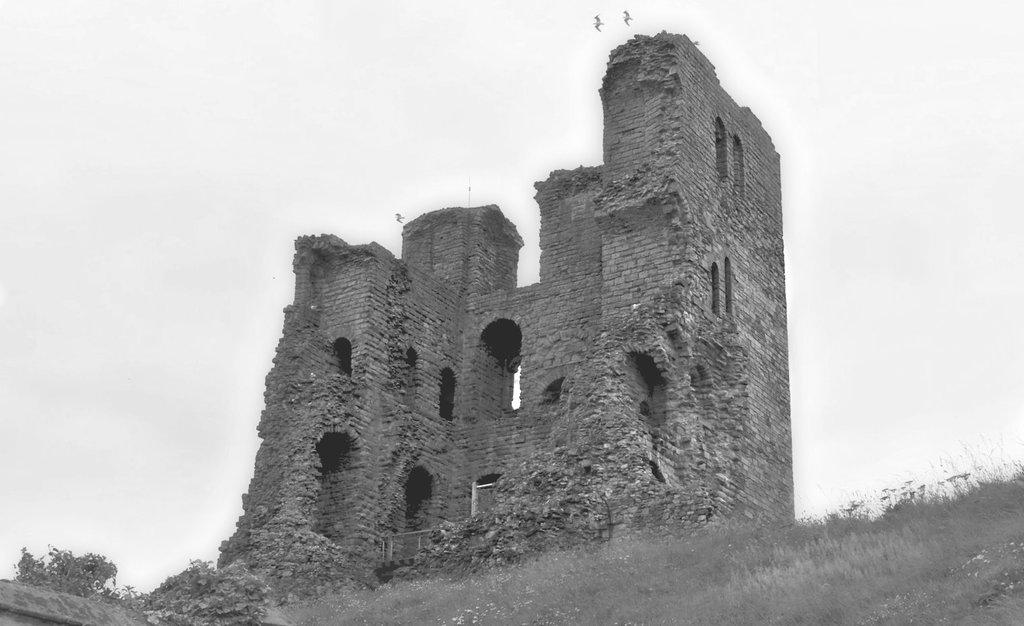What type of vegetation is in the foreground of the image? There is grass in the foreground of the image. What structure is located in the middle of the image? There is a fort in the middle of the image. What is visible at the top of the image? The sky is visible at the top of the image. How many birds can be seen in the sky? There are two birds in the sky. What type of fact can be seen in the image? There is no fact present in the image; it features grass, a fort, the sky, and two birds. What form of respect is shown by the fort in the image? The image does not depict any form of respect; it simply shows a fort in the middle of the image. 